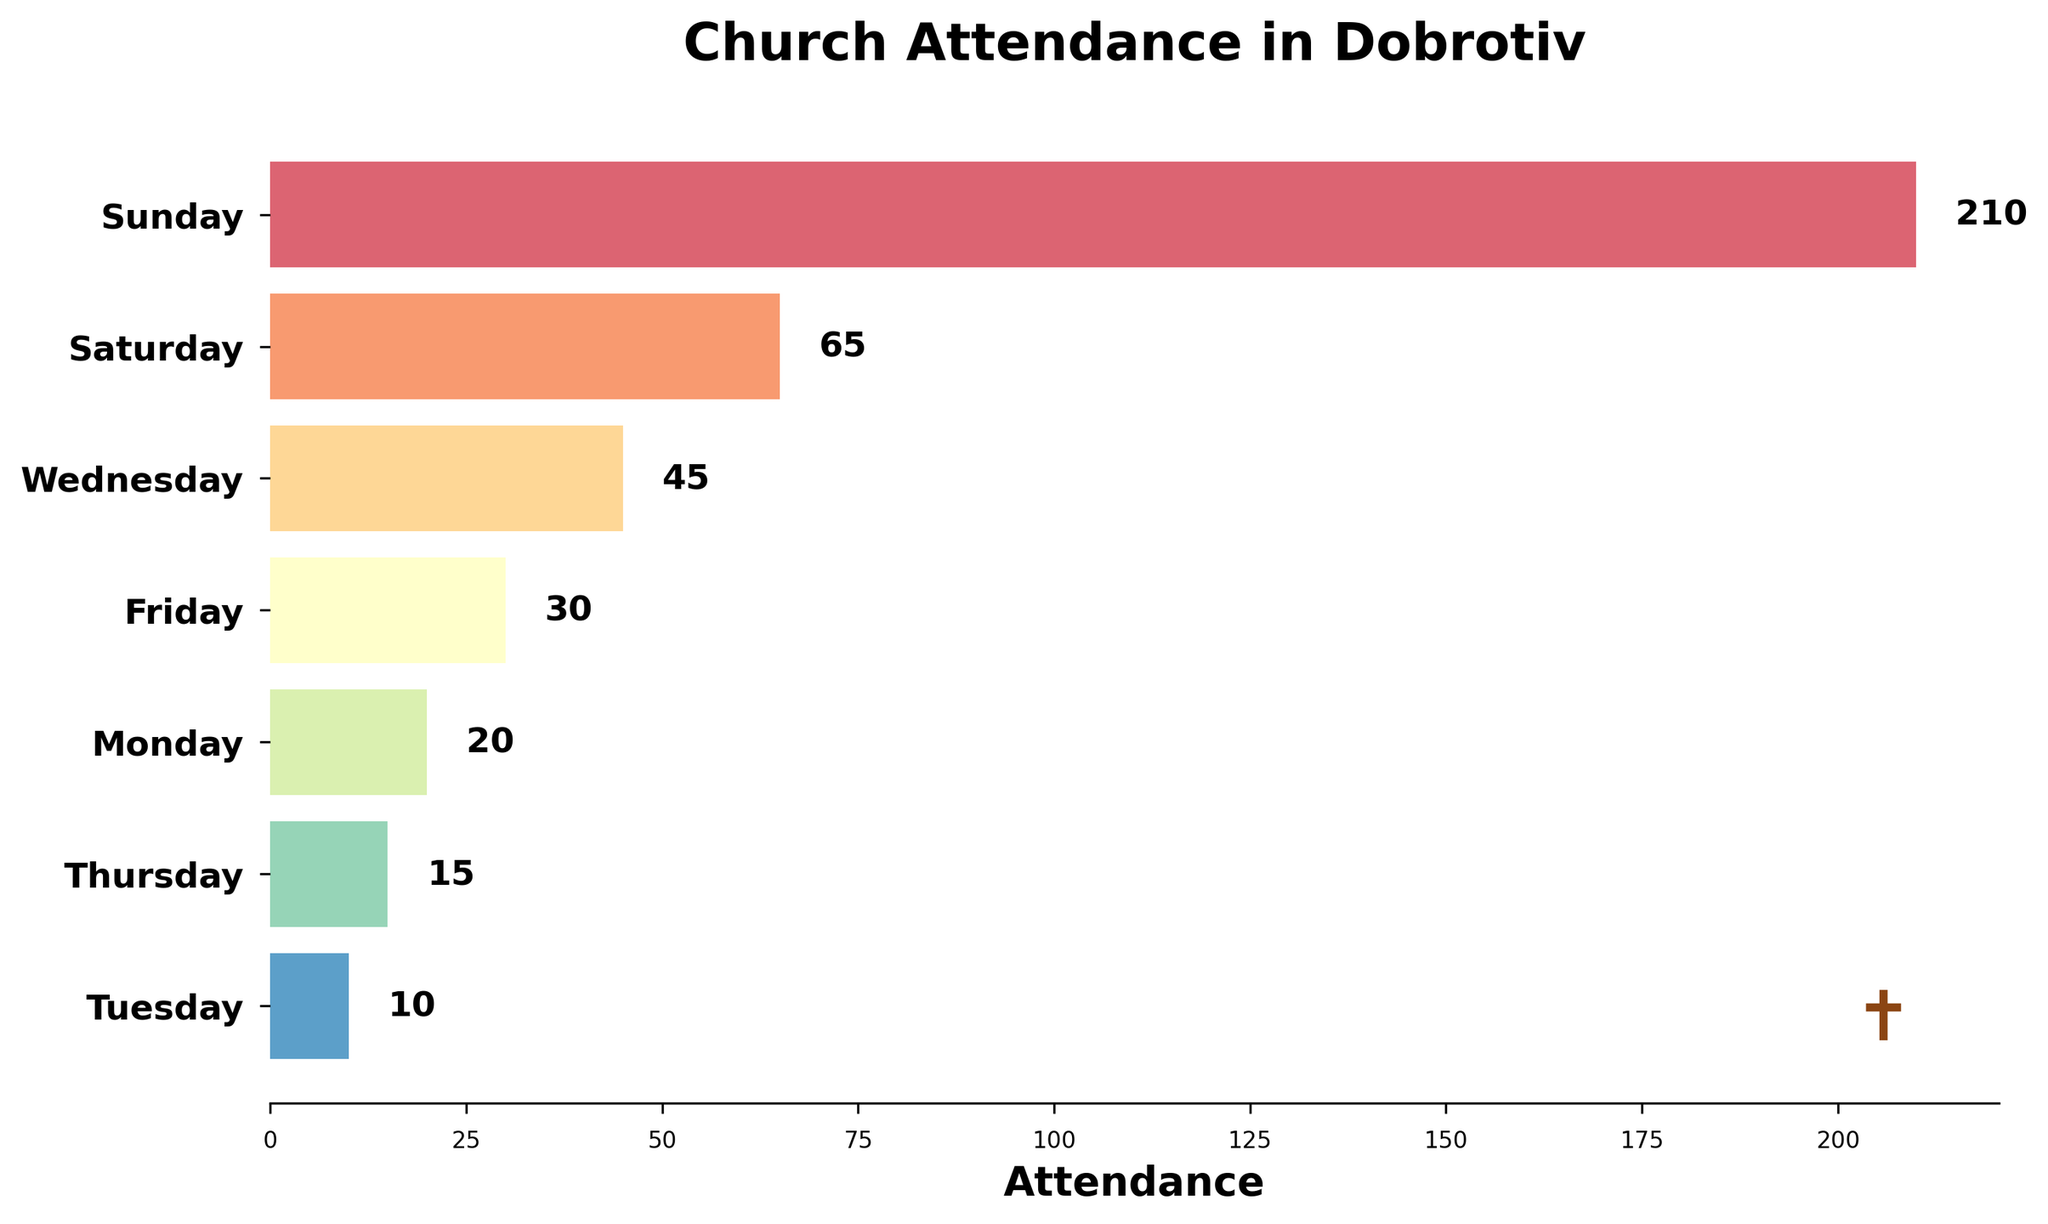What is the title of the figure? The title is usually located at the top of the figure. By looking at the top, you can see the text that describes the overall content of the figure.
Answer: Church Attendance in Dobrotiv Which day has the highest church attendance? Look at the lengths of the bars. The longest bar represents the day with the highest attendance.
Answer: Sunday How many different days are displayed in the figure? Count the number of bars or labels on the y-axis. Each bar or label represents one day.
Answer: 7 What is the attendance number for Saturday? Find the bar labeled "Saturday" and check the number at the end of the bar or the label associated with it.
Answer: 65 Which day has the lowest church attendance? Look for the shortest bar in the figure. This bar represents the day with the lowest attendance.
Answer: Tuesday What is the total church attendance from Monday to Wednesday? Add the attendance numbers for Monday, Tuesday, and Wednesday. The numbers are 20 (Monday), 10 (Tuesday), and 45 (Wednesday). So, 20 + 10 + 45 = 75.
Answer: 75 What is the average attendance from Sunday to Tuesday? Sum the attendance numbers for Sunday, Monday, and Tuesday, then divide by 3. The numbers are 210 (Sunday), 20 (Monday), and 10 (Tuesday). So, (210 + 20 + 10) / 3 = 240 / 3 = 80.
Answer: 80 How does the attendance on Wednesday compare to that on Friday? Compare the lengths of the bars for Wednesday and Friday. The numbers are 45 (Wednesday) and 30 (Friday).
Answer: Wednesday has higher attendance than Friday Which day has mid-range attendance and what is its attendance number? Arrange the days based on attendance and find the middle value. The sorted order is Tuesday (10), Thursday (15), Monday (20), Friday (30), Wednesday (45), Saturday (65), Sunday (210). The mid-range value is Wednesday with 45.
Answer: Wednesday, 45 What proportion of the total weekly attendance does Sunday represent? First, find the total weekly attendance by summing all the attendance numbers: 210 + 65 + 45 + 30 + 20 + 15 + 10 = 395. Then, divide Sunday’s attendance by the total and multiply by 100 to get a percentage: (210 / 395) * 100 ≈ 53.16%.
Answer: 53.16% 